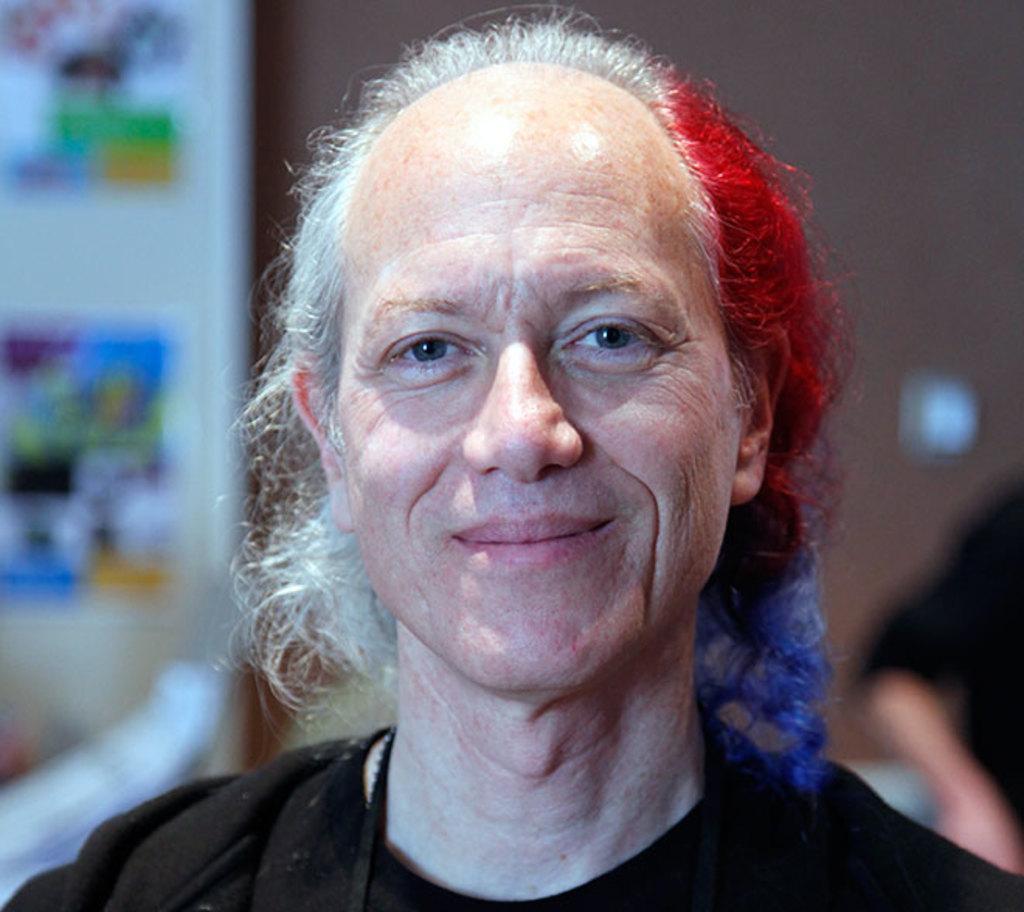How would you summarize this image in a sentence or two? This image consists of a person wearing a black dress. And the hair is in multicolor. The background is blurred. 